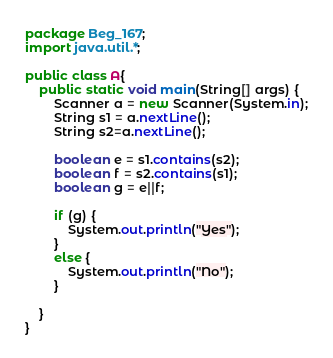Convert code to text. <code><loc_0><loc_0><loc_500><loc_500><_Java_>package Beg_167;
import java.util.*;

public class A{
	public static void main(String[] args) {
		Scanner a = new Scanner(System.in);
		String s1 = a.nextLine();
		String s2=a.nextLine();
		
		boolean e = s1.contains(s2);
		boolean f = s2.contains(s1);
		boolean g = e||f;
		
		if (g) {
			System.out.println("Yes");
		}
		else {
			System.out.println("No");
		}

	}
}</code> 